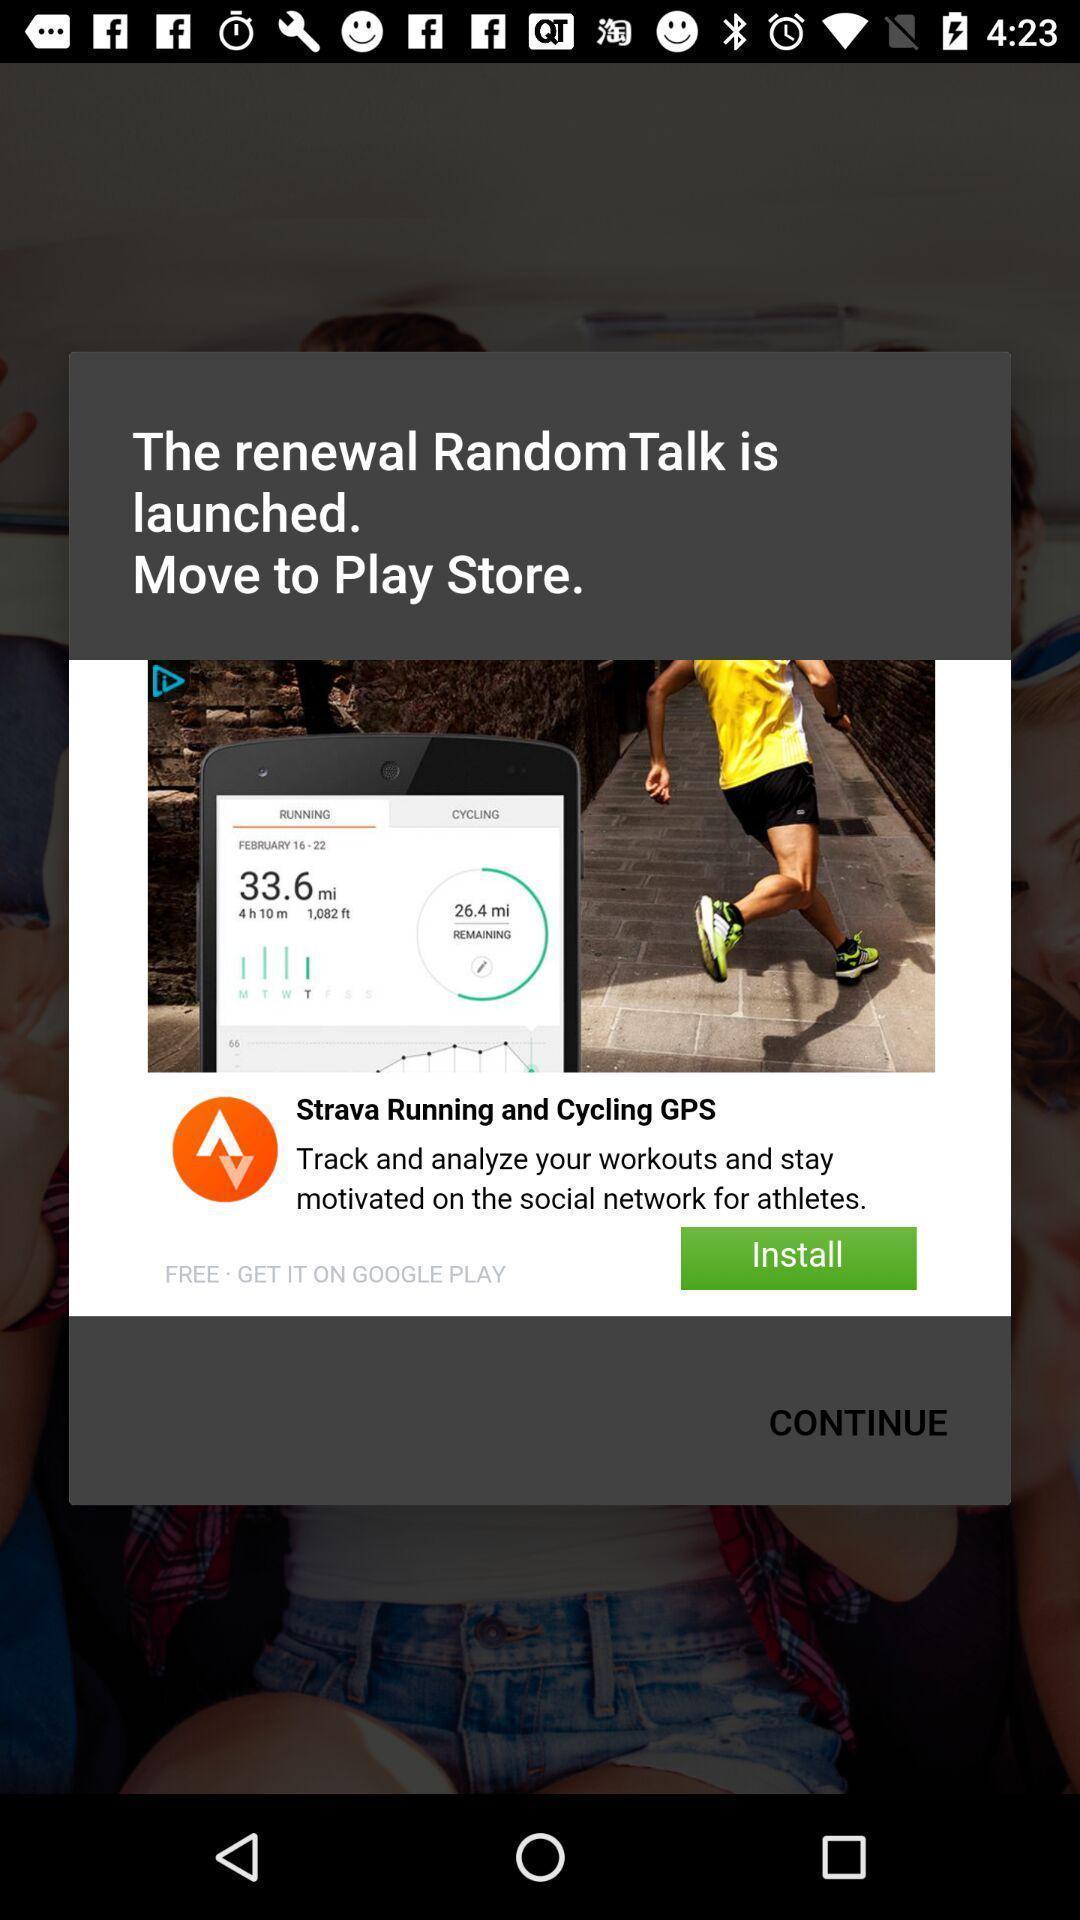Give me a summary of this screen capture. Pop-up window showing a social app to install. 